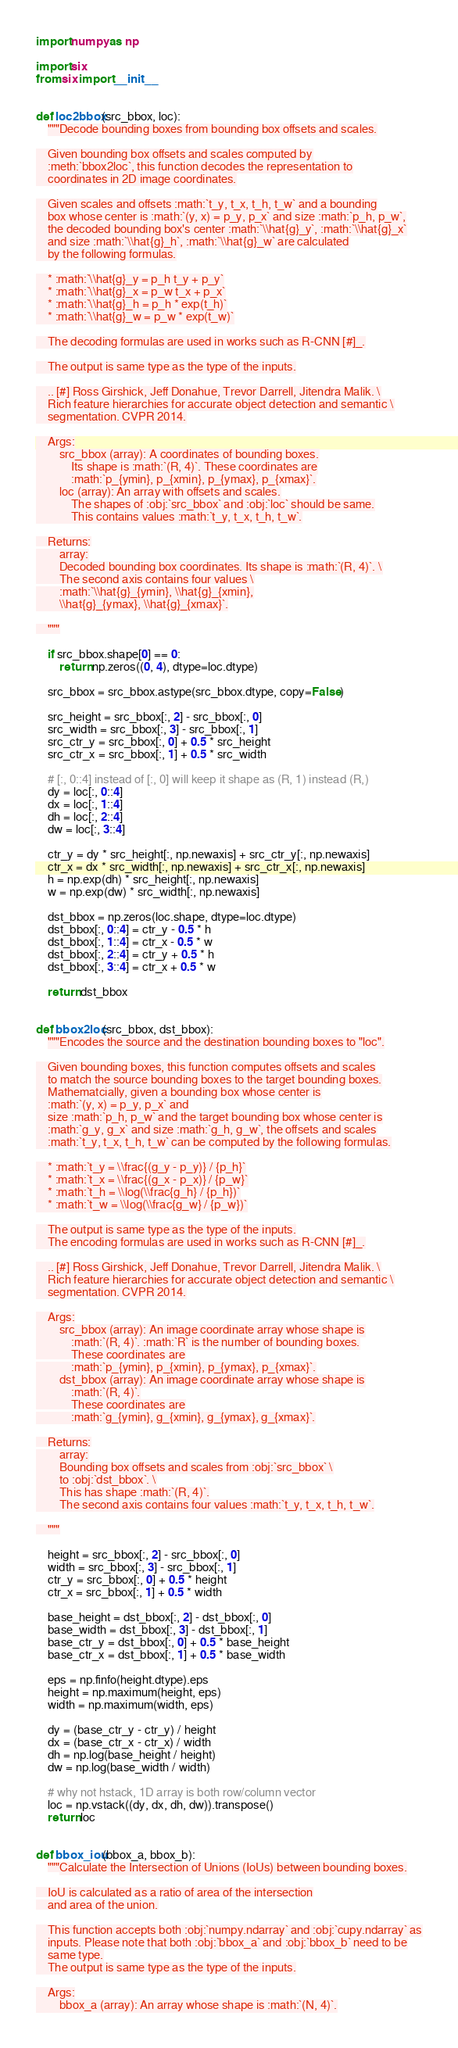Convert code to text. <code><loc_0><loc_0><loc_500><loc_500><_Python_>import numpy as np

import six
from six import __init__


def loc2bbox(src_bbox, loc):
    """Decode bounding boxes from bounding box offsets and scales.

    Given bounding box offsets and scales computed by
    :meth:`bbox2loc`, this function decodes the representation to
    coordinates in 2D image coordinates.

    Given scales and offsets :math:`t_y, t_x, t_h, t_w` and a bounding
    box whose center is :math:`(y, x) = p_y, p_x` and size :math:`p_h, p_w`,
    the decoded bounding box's center :math:`\\hat{g}_y`, :math:`\\hat{g}_x`
    and size :math:`\\hat{g}_h`, :math:`\\hat{g}_w` are calculated
    by the following formulas.

    * :math:`\\hat{g}_y = p_h t_y + p_y`
    * :math:`\\hat{g}_x = p_w t_x + p_x`
    * :math:`\\hat{g}_h = p_h * exp(t_h)`
    * :math:`\\hat{g}_w = p_w * exp(t_w)`

    The decoding formulas are used in works such as R-CNN [#]_.

    The output is same type as the type of the inputs.

    .. [#] Ross Girshick, Jeff Donahue, Trevor Darrell, Jitendra Malik. \
    Rich feature hierarchies for accurate object detection and semantic \
    segmentation. CVPR 2014.

    Args:
        src_bbox (array): A coordinates of bounding boxes.
            Its shape is :math:`(R, 4)`. These coordinates are
            :math:`p_{ymin}, p_{xmin}, p_{ymax}, p_{xmax}`.
        loc (array): An array with offsets and scales.
            The shapes of :obj:`src_bbox` and :obj:`loc` should be same.
            This contains values :math:`t_y, t_x, t_h, t_w`.

    Returns:
        array:
        Decoded bounding box coordinates. Its shape is :math:`(R, 4)`. \
        The second axis contains four values \
        :math:`\\hat{g}_{ymin}, \\hat{g}_{xmin},
        \\hat{g}_{ymax}, \\hat{g}_{xmax}`.

    """

    if src_bbox.shape[0] == 0:
        return np.zeros((0, 4), dtype=loc.dtype)

    src_bbox = src_bbox.astype(src_bbox.dtype, copy=False)

    src_height = src_bbox[:, 2] - src_bbox[:, 0]
    src_width = src_bbox[:, 3] - src_bbox[:, 1]
    src_ctr_y = src_bbox[:, 0] + 0.5 * src_height
    src_ctr_x = src_bbox[:, 1] + 0.5 * src_width

    # [:, 0::4] instead of [:, 0] will keep it shape as (R, 1) instead (R,)
    dy = loc[:, 0::4]
    dx = loc[:, 1::4]
    dh = loc[:, 2::4]
    dw = loc[:, 3::4]

    ctr_y = dy * src_height[:, np.newaxis] + src_ctr_y[:, np.newaxis]
    ctr_x = dx * src_width[:, np.newaxis] + src_ctr_x[:, np.newaxis]
    h = np.exp(dh) * src_height[:, np.newaxis]
    w = np.exp(dw) * src_width[:, np.newaxis]

    dst_bbox = np.zeros(loc.shape, dtype=loc.dtype)
    dst_bbox[:, 0::4] = ctr_y - 0.5 * h
    dst_bbox[:, 1::4] = ctr_x - 0.5 * w
    dst_bbox[:, 2::4] = ctr_y + 0.5 * h
    dst_bbox[:, 3::4] = ctr_x + 0.5 * w

    return dst_bbox


def bbox2loc(src_bbox, dst_bbox):
    """Encodes the source and the destination bounding boxes to "loc".

    Given bounding boxes, this function computes offsets and scales
    to match the source bounding boxes to the target bounding boxes.
    Mathematcially, given a bounding box whose center is
    :math:`(y, x) = p_y, p_x` and
    size :math:`p_h, p_w` and the target bounding box whose center is
    :math:`g_y, g_x` and size :math:`g_h, g_w`, the offsets and scales
    :math:`t_y, t_x, t_h, t_w` can be computed by the following formulas.

    * :math:`t_y = \\frac{(g_y - p_y)} / {p_h}`
    * :math:`t_x = \\frac{(g_x - p_x)} / {p_w}`
    * :math:`t_h = \\log(\\frac{g_h} / {p_h})`
    * :math:`t_w = \\log(\\frac{g_w} / {p_w})`

    The output is same type as the type of the inputs.
    The encoding formulas are used in works such as R-CNN [#]_.

    .. [#] Ross Girshick, Jeff Donahue, Trevor Darrell, Jitendra Malik. \
    Rich feature hierarchies for accurate object detection and semantic \
    segmentation. CVPR 2014.

    Args:
        src_bbox (array): An image coordinate array whose shape is
            :math:`(R, 4)`. :math:`R` is the number of bounding boxes.
            These coordinates are
            :math:`p_{ymin}, p_{xmin}, p_{ymax}, p_{xmax}`.
        dst_bbox (array): An image coordinate array whose shape is
            :math:`(R, 4)`.
            These coordinates are
            :math:`g_{ymin}, g_{xmin}, g_{ymax}, g_{xmax}`.

    Returns:
        array:
        Bounding box offsets and scales from :obj:`src_bbox` \
        to :obj:`dst_bbox`. \
        This has shape :math:`(R, 4)`.
        The second axis contains four values :math:`t_y, t_x, t_h, t_w`.

    """

    height = src_bbox[:, 2] - src_bbox[:, 0]
    width = src_bbox[:, 3] - src_bbox[:, 1]
    ctr_y = src_bbox[:, 0] + 0.5 * height
    ctr_x = src_bbox[:, 1] + 0.5 * width

    base_height = dst_bbox[:, 2] - dst_bbox[:, 0]
    base_width = dst_bbox[:, 3] - dst_bbox[:, 1]
    base_ctr_y = dst_bbox[:, 0] + 0.5 * base_height
    base_ctr_x = dst_bbox[:, 1] + 0.5 * base_width

    eps = np.finfo(height.dtype).eps
    height = np.maximum(height, eps)
    width = np.maximum(width, eps)

    dy = (base_ctr_y - ctr_y) / height
    dx = (base_ctr_x - ctr_x) / width
    dh = np.log(base_height / height)
    dw = np.log(base_width / width)

    # why not hstack, 1D array is both row/column vector
    loc = np.vstack((dy, dx, dh, dw)).transpose()
    return loc


def bbox_iou(bbox_a, bbox_b):
    """Calculate the Intersection of Unions (IoUs) between bounding boxes.

    IoU is calculated as a ratio of area of the intersection
    and area of the union.

    This function accepts both :obj:`numpy.ndarray` and :obj:`cupy.ndarray` as
    inputs. Please note that both :obj:`bbox_a` and :obj:`bbox_b` need to be
    same type.
    The output is same type as the type of the inputs.

    Args:
        bbox_a (array): An array whose shape is :math:`(N, 4)`.</code> 